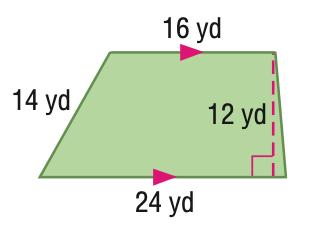Answer the mathemtical geometry problem and directly provide the correct option letter.
Question: Find the area of the quadrilateral.
Choices: A: 168 B: 192 C: 240 D: 288 C 